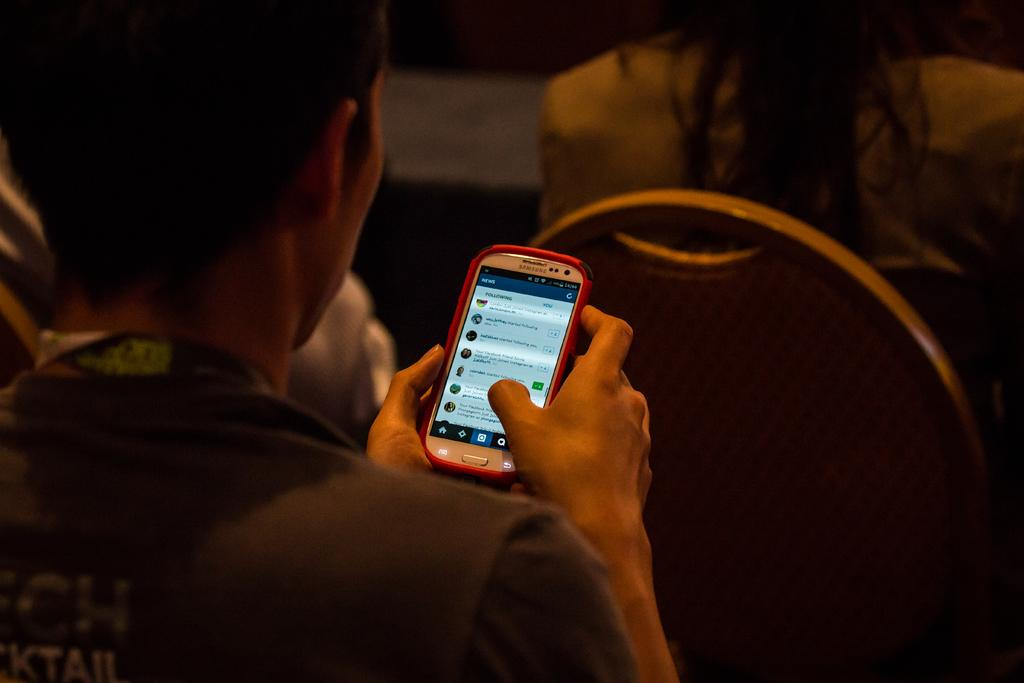What is the person in the image doing with the camera? The person is taking a picture. What can be seen in the background of the image? There is a mountain in the background. What type of work is the mountain doing in the image? The mountain is not performing any work; it is a geological formation. How many stitches are visible on the person's clothing in the image? There is no information about the person's clothing or stitches in the image. --- Facts: 1. There is a person sitting on a bench in the image. 2. The person is reading a book. 3. There is a tree next to the bench. 4. The sky is visible in the image. Absurd Topics: dance, rainbow, guitar Conversation: What is the person in the image doing? The person is sitting on a bench and reading a book. What can be seen next to the bench in the image? There is a tree next to the bench. What is visible in the background of the image? The sky is visible in the image. Reasoning: Let's think step by step in order to produce the conversation. We start by identifying the main subject in the image, which is the person sitting on a bench. Then, we expand the conversation to include the action the person is performing, which is reading a book. Finally, we describe the surroundings of the bench, which include a tree and the sky. Absurd Question/Answer: What type of dance is the tree performing in the image? Trees do not perform dances; they are plants. Can you see a rainbow in the image? There is no mention of a rainbow in the image, and it is not visible in the provided facts. 